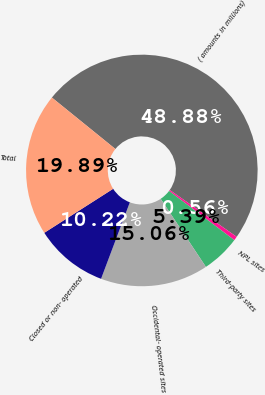Convert chart to OTSL. <chart><loc_0><loc_0><loc_500><loc_500><pie_chart><fcel>( amounts in millions)<fcel>NPL sites<fcel>Third-party sites<fcel>Occidental- operated sites<fcel>Closed or non- operated<fcel>Total<nl><fcel>48.88%<fcel>0.56%<fcel>5.39%<fcel>15.06%<fcel>10.22%<fcel>19.89%<nl></chart> 